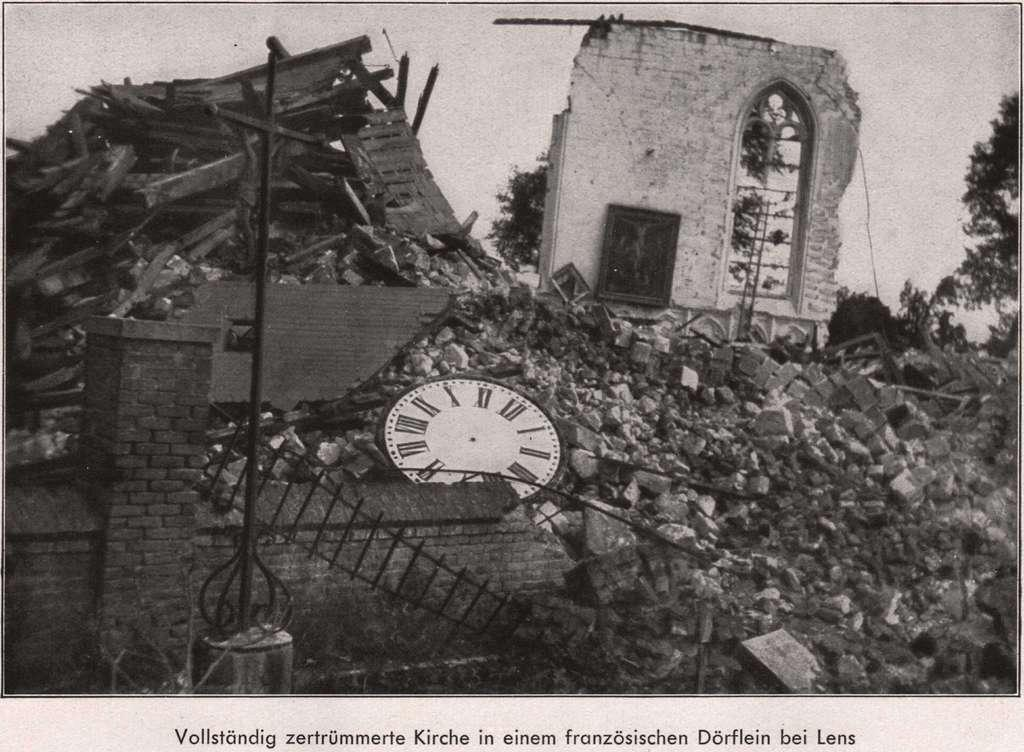Provide a one-sentence caption for the provided image. A picture of rubble with a German caption. 